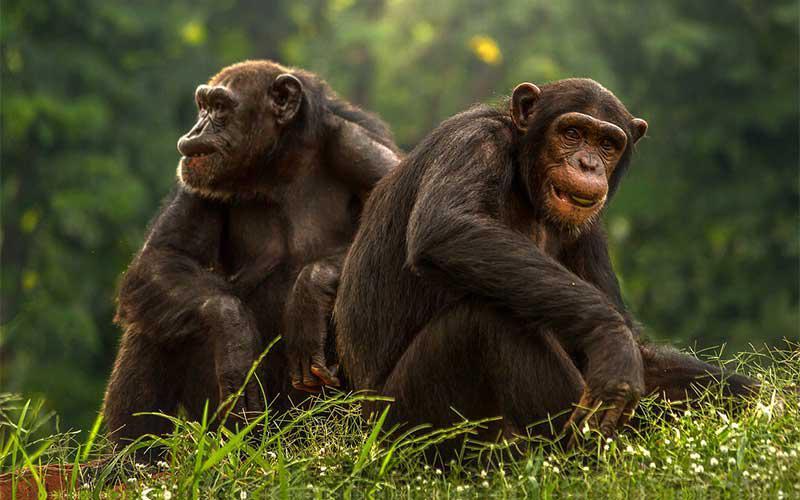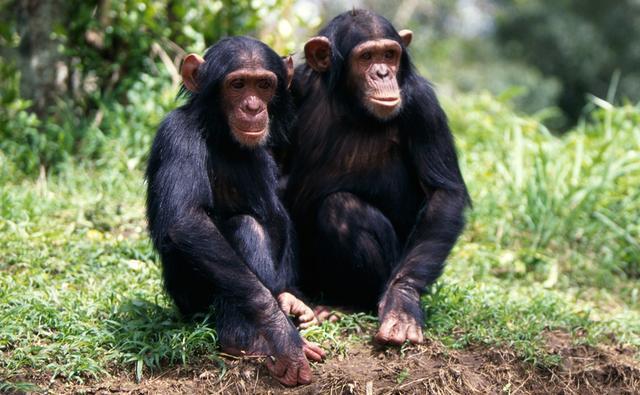The first image is the image on the left, the second image is the image on the right. Assess this claim about the two images: "There is at least one money on the right that is showing its teeth". Correct or not? Answer yes or no. No. The first image is the image on the left, the second image is the image on the right. For the images shown, is this caption "Each image shows two chimps posed side-by-side, but no chimp has a hand visibly grabbing the other chimp or a wide-open mouth." true? Answer yes or no. Yes. 